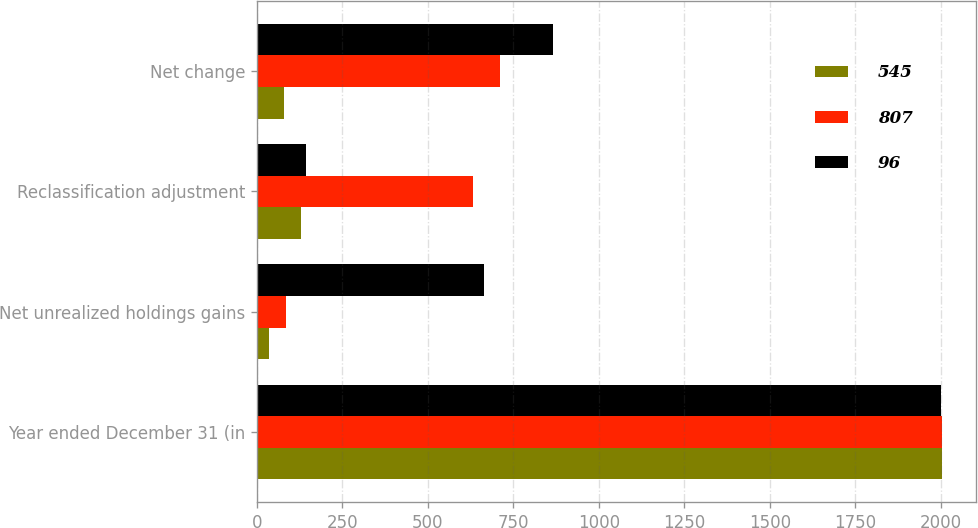Convert chart. <chart><loc_0><loc_0><loc_500><loc_500><stacked_bar_chart><ecel><fcel>Year ended December 31 (in<fcel>Net unrealized holdings gains<fcel>Reclassification adjustment<fcel>Net change<nl><fcel>545<fcel>2004<fcel>34<fcel>130<fcel>80<nl><fcel>807<fcel>2003<fcel>86<fcel>631<fcel>712<nl><fcel>96<fcel>2002<fcel>663<fcel>144<fcel>866<nl></chart> 